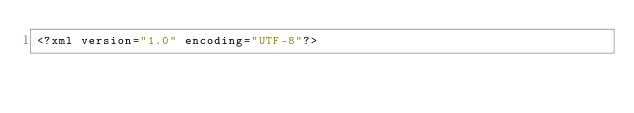<code> <loc_0><loc_0><loc_500><loc_500><_XML_><?xml version="1.0" encoding="UTF-8"?></code> 